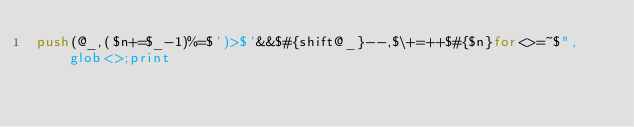Convert code to text. <code><loc_0><loc_0><loc_500><loc_500><_Perl_>push(@_,($n+=$_-1)%=$')>$'&&$#{shift@_}--,$\+=++$#{$n}for<>=~$",glob<>;print</code> 